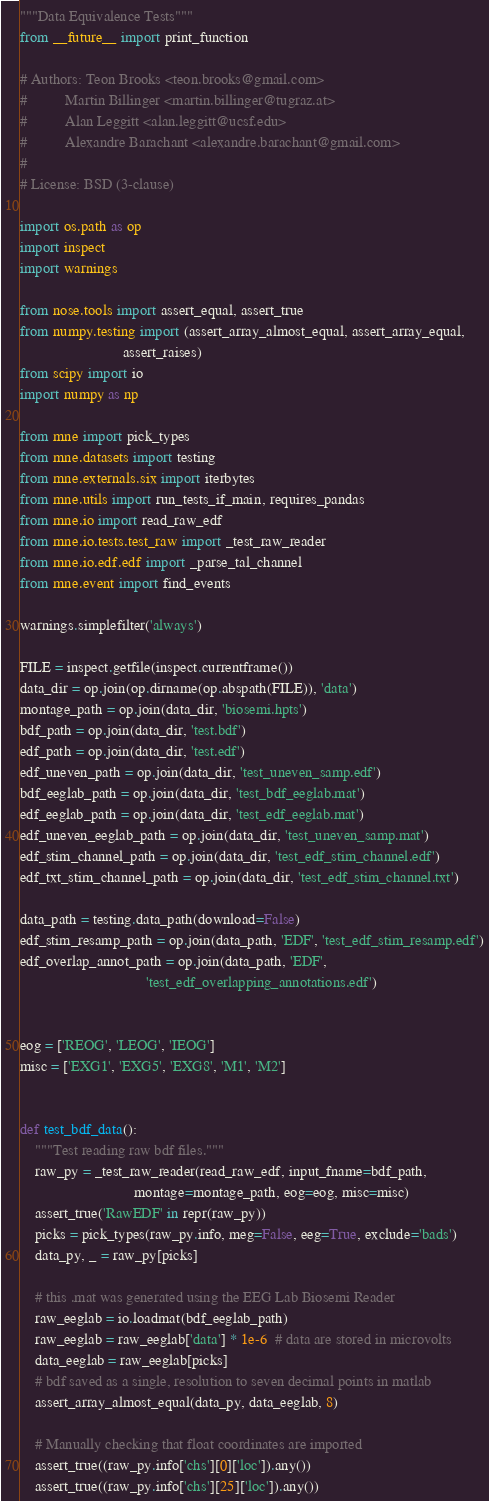Convert code to text. <code><loc_0><loc_0><loc_500><loc_500><_Python_>"""Data Equivalence Tests"""
from __future__ import print_function

# Authors: Teon Brooks <teon.brooks@gmail.com>
#          Martin Billinger <martin.billinger@tugraz.at>
#          Alan Leggitt <alan.leggitt@ucsf.edu>
#          Alexandre Barachant <alexandre.barachant@gmail.com>
#
# License: BSD (3-clause)

import os.path as op
import inspect
import warnings

from nose.tools import assert_equal, assert_true
from numpy.testing import (assert_array_almost_equal, assert_array_equal,
                           assert_raises)
from scipy import io
import numpy as np

from mne import pick_types
from mne.datasets import testing
from mne.externals.six import iterbytes
from mne.utils import run_tests_if_main, requires_pandas
from mne.io import read_raw_edf
from mne.io.tests.test_raw import _test_raw_reader
from mne.io.edf.edf import _parse_tal_channel
from mne.event import find_events

warnings.simplefilter('always')

FILE = inspect.getfile(inspect.currentframe())
data_dir = op.join(op.dirname(op.abspath(FILE)), 'data')
montage_path = op.join(data_dir, 'biosemi.hpts')
bdf_path = op.join(data_dir, 'test.bdf')
edf_path = op.join(data_dir, 'test.edf')
edf_uneven_path = op.join(data_dir, 'test_uneven_samp.edf')
bdf_eeglab_path = op.join(data_dir, 'test_bdf_eeglab.mat')
edf_eeglab_path = op.join(data_dir, 'test_edf_eeglab.mat')
edf_uneven_eeglab_path = op.join(data_dir, 'test_uneven_samp.mat')
edf_stim_channel_path = op.join(data_dir, 'test_edf_stim_channel.edf')
edf_txt_stim_channel_path = op.join(data_dir, 'test_edf_stim_channel.txt')

data_path = testing.data_path(download=False)
edf_stim_resamp_path = op.join(data_path, 'EDF', 'test_edf_stim_resamp.edf')
edf_overlap_annot_path = op.join(data_path, 'EDF',
                                 'test_edf_overlapping_annotations.edf')


eog = ['REOG', 'LEOG', 'IEOG']
misc = ['EXG1', 'EXG5', 'EXG8', 'M1', 'M2']


def test_bdf_data():
    """Test reading raw bdf files."""
    raw_py = _test_raw_reader(read_raw_edf, input_fname=bdf_path,
                              montage=montage_path, eog=eog, misc=misc)
    assert_true('RawEDF' in repr(raw_py))
    picks = pick_types(raw_py.info, meg=False, eeg=True, exclude='bads')
    data_py, _ = raw_py[picks]

    # this .mat was generated using the EEG Lab Biosemi Reader
    raw_eeglab = io.loadmat(bdf_eeglab_path)
    raw_eeglab = raw_eeglab['data'] * 1e-6  # data are stored in microvolts
    data_eeglab = raw_eeglab[picks]
    # bdf saved as a single, resolution to seven decimal points in matlab
    assert_array_almost_equal(data_py, data_eeglab, 8)

    # Manually checking that float coordinates are imported
    assert_true((raw_py.info['chs'][0]['loc']).any())
    assert_true((raw_py.info['chs'][25]['loc']).any())</code> 